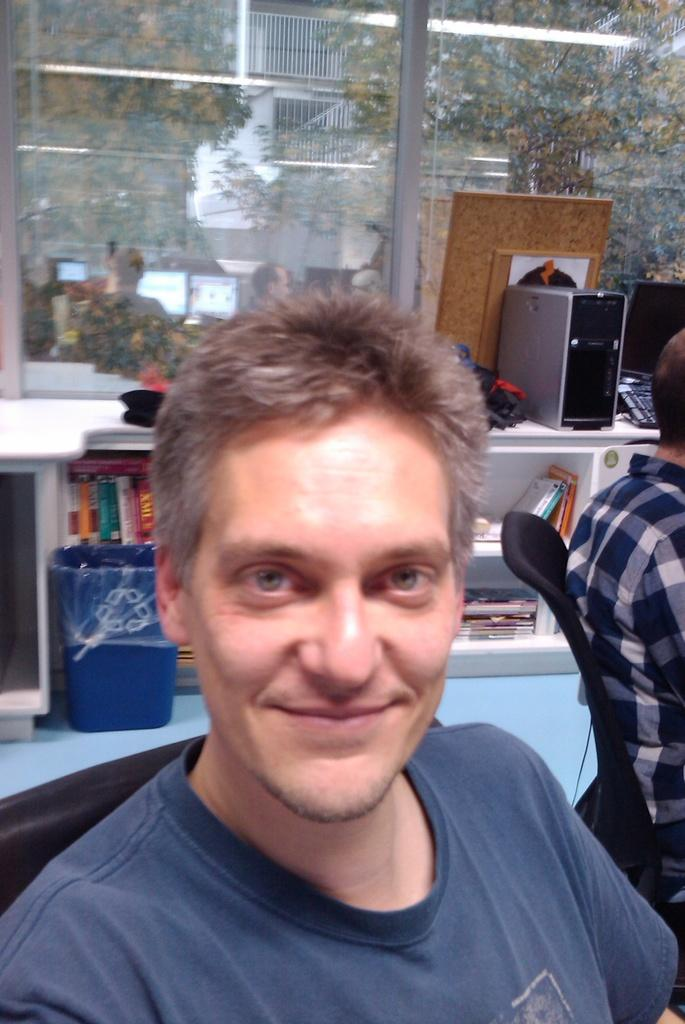What is the main subject of the image? There is a person in the image. What else can be seen in the image besides the person? There are things on a desk in the image. Are there any other people visible in the image? Yes, there is another person to the side of the first person in the image. What type of territory does the frog claim in the image? There is no frog present in the image, so it cannot claim any territory. 